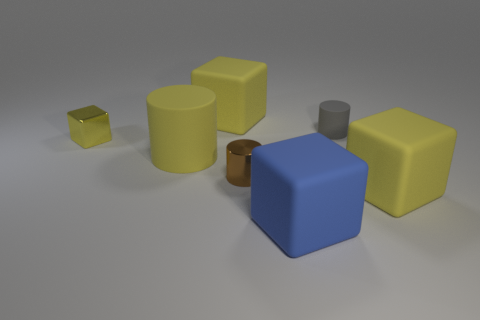There is a tiny rubber object; are there any tiny cylinders on the left side of it?
Your response must be concise. Yes. There is a gray matte thing; what shape is it?
Provide a short and direct response. Cylinder. How many things are large yellow rubber things in front of the small cube or small gray objects?
Ensure brevity in your answer.  3. What number of other objects are the same color as the large matte cylinder?
Offer a terse response. 3. There is a tiny shiny cylinder; does it have the same color as the metallic thing that is behind the tiny shiny cylinder?
Ensure brevity in your answer.  No. What color is the large object that is the same shape as the tiny gray matte thing?
Make the answer very short. Yellow. Are the brown cylinder and the large block on the right side of the gray rubber object made of the same material?
Offer a terse response. No. What color is the metallic cylinder?
Keep it short and to the point. Brown. What is the color of the big block behind the big yellow matte block in front of the yellow cube that is behind the tiny yellow block?
Keep it short and to the point. Yellow. There is a brown thing; is its shape the same as the big thing that is behind the yellow matte cylinder?
Provide a short and direct response. No. 